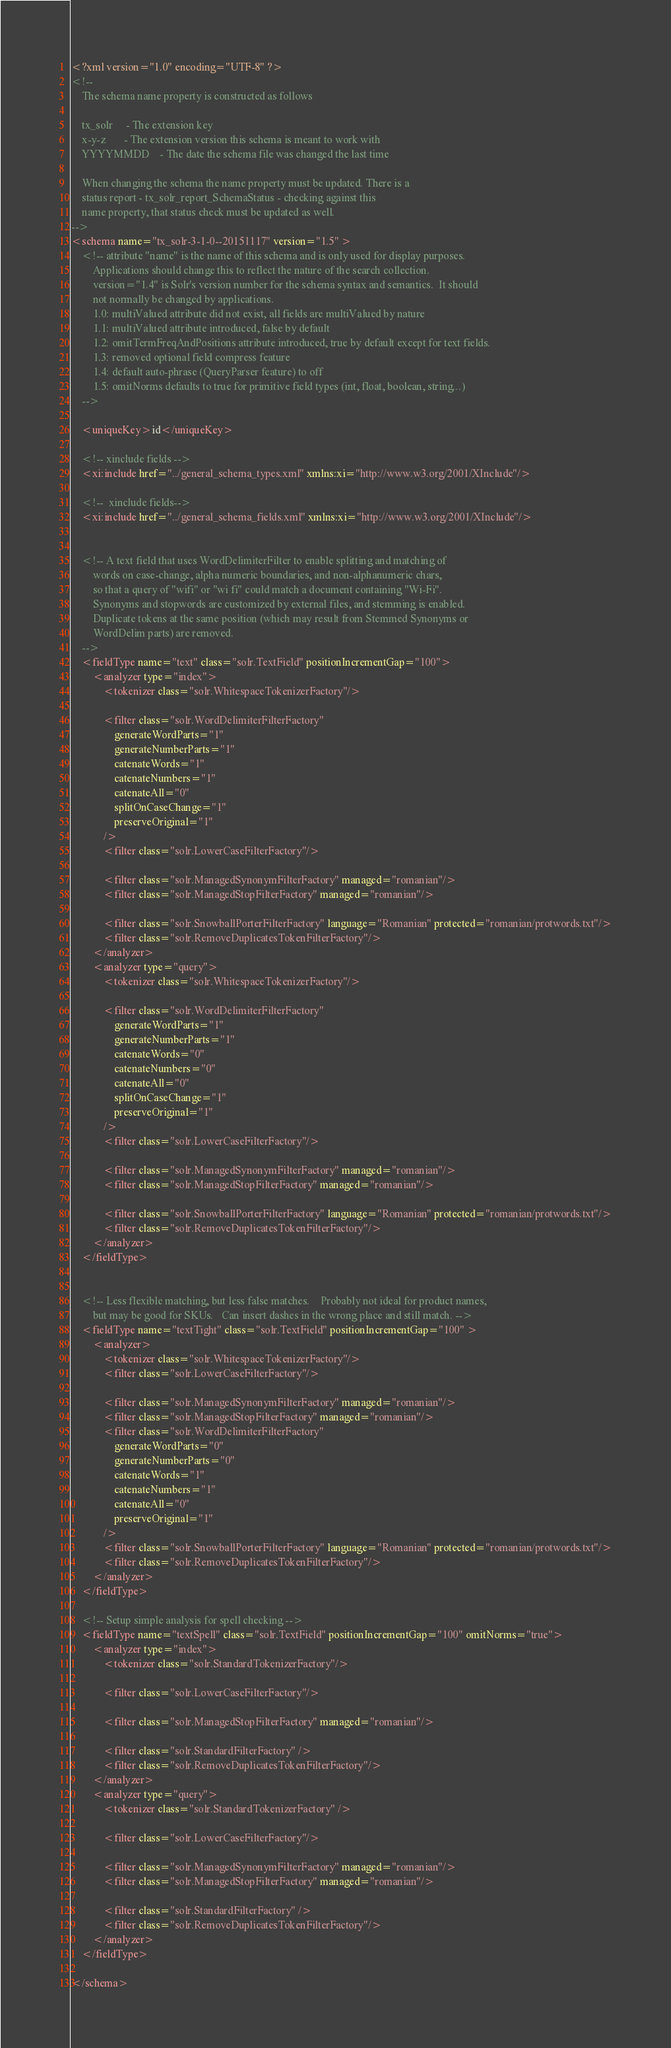Convert code to text. <code><loc_0><loc_0><loc_500><loc_500><_XML_><?xml version="1.0" encoding="UTF-8" ?>
<!--
	The schema name property is constructed as follows

	tx_solr		- The extension key
	x-y-z		- The extension version this schema is meant to work with
	YYYYMMDD	- The date the schema file was changed the last time

	When changing the schema the name property must be updated. There is a
	status report - tx_solr_report_SchemaStatus - checking against this
	name property, that status check must be updated as well.
-->
<schema name="tx_solr-3-1-0--20151117" version="1.5" >
	<!-- attribute "name" is the name of this schema and is only used for display purposes.
		Applications should change this to reflect the nature of the search collection.
		version="1.4" is Solr's version number for the schema syntax and semantics.  It should
		not normally be changed by applications.
		1.0: multiValued attribute did not exist, all fields are multiValued by nature
		1.1: multiValued attribute introduced, false by default 
		1.2: omitTermFreqAndPositions attribute introduced, true by default except for text fields.
		1.3: removed optional field compress feature
		1.4: default auto-phrase (QueryParser feature) to off
		1.5: omitNorms defaults to true for primitive field types (int, float, boolean, string...)
	-->

	<uniqueKey>id</uniqueKey>

	<!-- xinclude fields -->
	<xi:include href="../general_schema_types.xml" xmlns:xi="http://www.w3.org/2001/XInclude"/>

	<!--  xinclude fields-->
	<xi:include href="../general_schema_fields.xml" xmlns:xi="http://www.w3.org/2001/XInclude"/>


	<!-- A text field that uses WordDelimiterFilter to enable splitting and matching of
		words on case-change, alpha numeric boundaries, and non-alphanumeric chars,
		so that a query of "wifi" or "wi fi" could match a document containing "Wi-Fi".
		Synonyms and stopwords are customized by external files, and stemming is enabled.
		Duplicate tokens at the same position (which may result from Stemmed Synonyms or
		WordDelim parts) are removed.
	-->
	<fieldType name="text" class="solr.TextField" positionIncrementGap="100">
		<analyzer type="index">
			<tokenizer class="solr.WhitespaceTokenizerFactory"/>

			<filter class="solr.WordDelimiterFilterFactory"
				generateWordParts="1"
				generateNumberParts="1"
				catenateWords="1"
				catenateNumbers="1"
				catenateAll="0"
				splitOnCaseChange="1"
				preserveOriginal="1"
			/>
			<filter class="solr.LowerCaseFilterFactory"/>

			<filter class="solr.ManagedSynonymFilterFactory" managed="romanian"/>
			<filter class="solr.ManagedStopFilterFactory" managed="romanian"/>

			<filter class="solr.SnowballPorterFilterFactory" language="Romanian" protected="romanian/protwords.txt"/>
			<filter class="solr.RemoveDuplicatesTokenFilterFactory"/>
		</analyzer>
		<analyzer type="query">
			<tokenizer class="solr.WhitespaceTokenizerFactory"/>

			<filter class="solr.WordDelimiterFilterFactory"
				generateWordParts="1"
				generateNumberParts="1"
				catenateWords="0"
				catenateNumbers="0"
				catenateAll="0"
				splitOnCaseChange="1"
				preserveOriginal="1"
			/>
			<filter class="solr.LowerCaseFilterFactory"/>

			<filter class="solr.ManagedSynonymFilterFactory" managed="romanian"/>
			<filter class="solr.ManagedStopFilterFactory" managed="romanian"/>

			<filter class="solr.SnowballPorterFilterFactory" language="Romanian" protected="romanian/protwords.txt"/>
			<filter class="solr.RemoveDuplicatesTokenFilterFactory"/>
		</analyzer>
	</fieldType>


	<!-- Less flexible matching, but less false matches.	Probably not ideal for product names,
		but may be good for SKUs.	Can insert dashes in the wrong place and still match. -->
	<fieldType name="textTight" class="solr.TextField" positionIncrementGap="100" >
		<analyzer>
			<tokenizer class="solr.WhitespaceTokenizerFactory"/>
			<filter class="solr.LowerCaseFilterFactory"/>

			<filter class="solr.ManagedSynonymFilterFactory" managed="romanian"/>
			<filter class="solr.ManagedStopFilterFactory" managed="romanian"/>
			<filter class="solr.WordDelimiterFilterFactory"
				generateWordParts="0"
				generateNumberParts="0"
				catenateWords="1"
				catenateNumbers="1"
				catenateAll="0"
				preserveOriginal="1"
			/>
			<filter class="solr.SnowballPorterFilterFactory" language="Romanian" protected="romanian/protwords.txt"/>
			<filter class="solr.RemoveDuplicatesTokenFilterFactory"/>
		</analyzer>
	</fieldType>

	<!-- Setup simple analysis for spell checking -->
	<fieldType name="textSpell" class="solr.TextField" positionIncrementGap="100" omitNorms="true">
		<analyzer type="index">
			<tokenizer class="solr.StandardTokenizerFactory"/>

			<filter class="solr.LowerCaseFilterFactory"/>

			<filter class="solr.ManagedStopFilterFactory" managed="romanian"/>

			<filter class="solr.StandardFilterFactory" />
			<filter class="solr.RemoveDuplicatesTokenFilterFactory"/>
		</analyzer>
		<analyzer type="query">
			<tokenizer class="solr.StandardTokenizerFactory" />

			<filter class="solr.LowerCaseFilterFactory"/>

			<filter class="solr.ManagedSynonymFilterFactory" managed="romanian"/>
			<filter class="solr.ManagedStopFilterFactory" managed="romanian"/>

			<filter class="solr.StandardFilterFactory" />
			<filter class="solr.RemoveDuplicatesTokenFilterFactory"/>
		</analyzer>
	</fieldType>

</schema></code> 